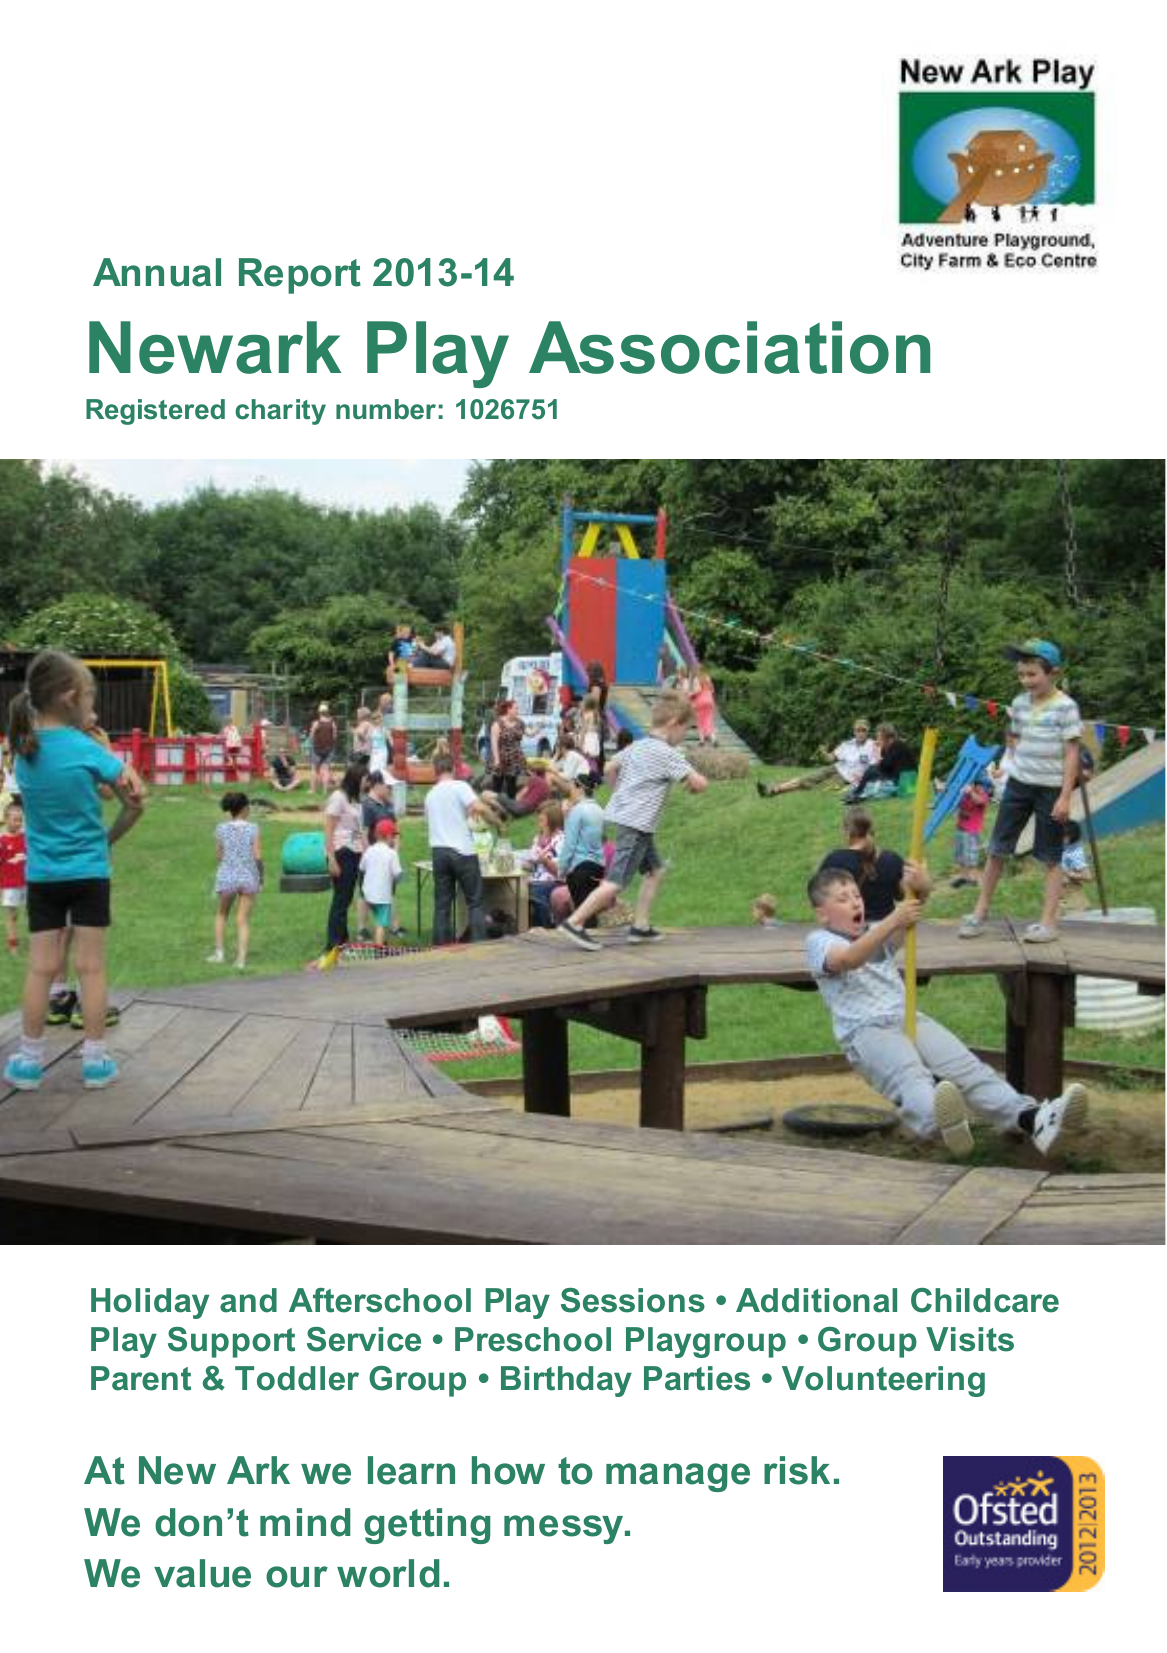What is the value for the address__post_town?
Answer the question using a single word or phrase. PETERBOROUGH 